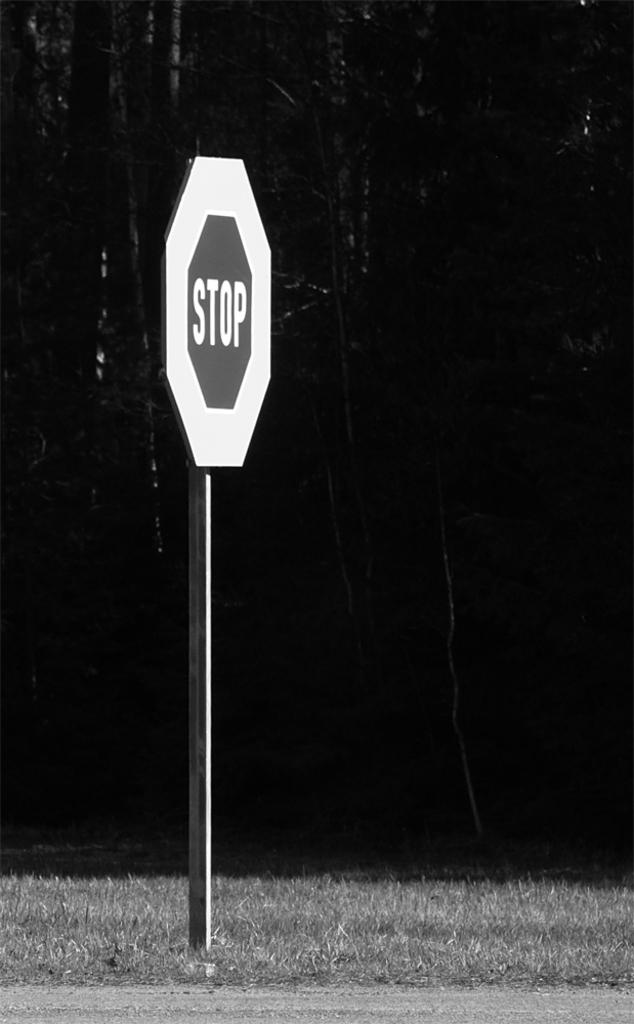<image>
Present a compact description of the photo's key features. A stop sign outlined  in white in front of a copse of trees. 